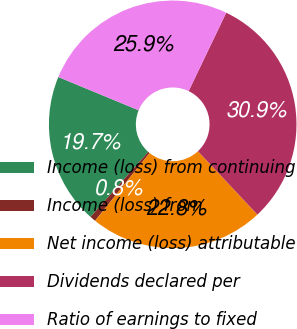Convert chart to OTSL. <chart><loc_0><loc_0><loc_500><loc_500><pie_chart><fcel>Income (loss) from continuing<fcel>Income (loss) from<fcel>Net income (loss) attributable<fcel>Dividends declared per<fcel>Ratio of earnings to fixed<nl><fcel>19.69%<fcel>0.77%<fcel>22.78%<fcel>30.89%<fcel>25.87%<nl></chart> 